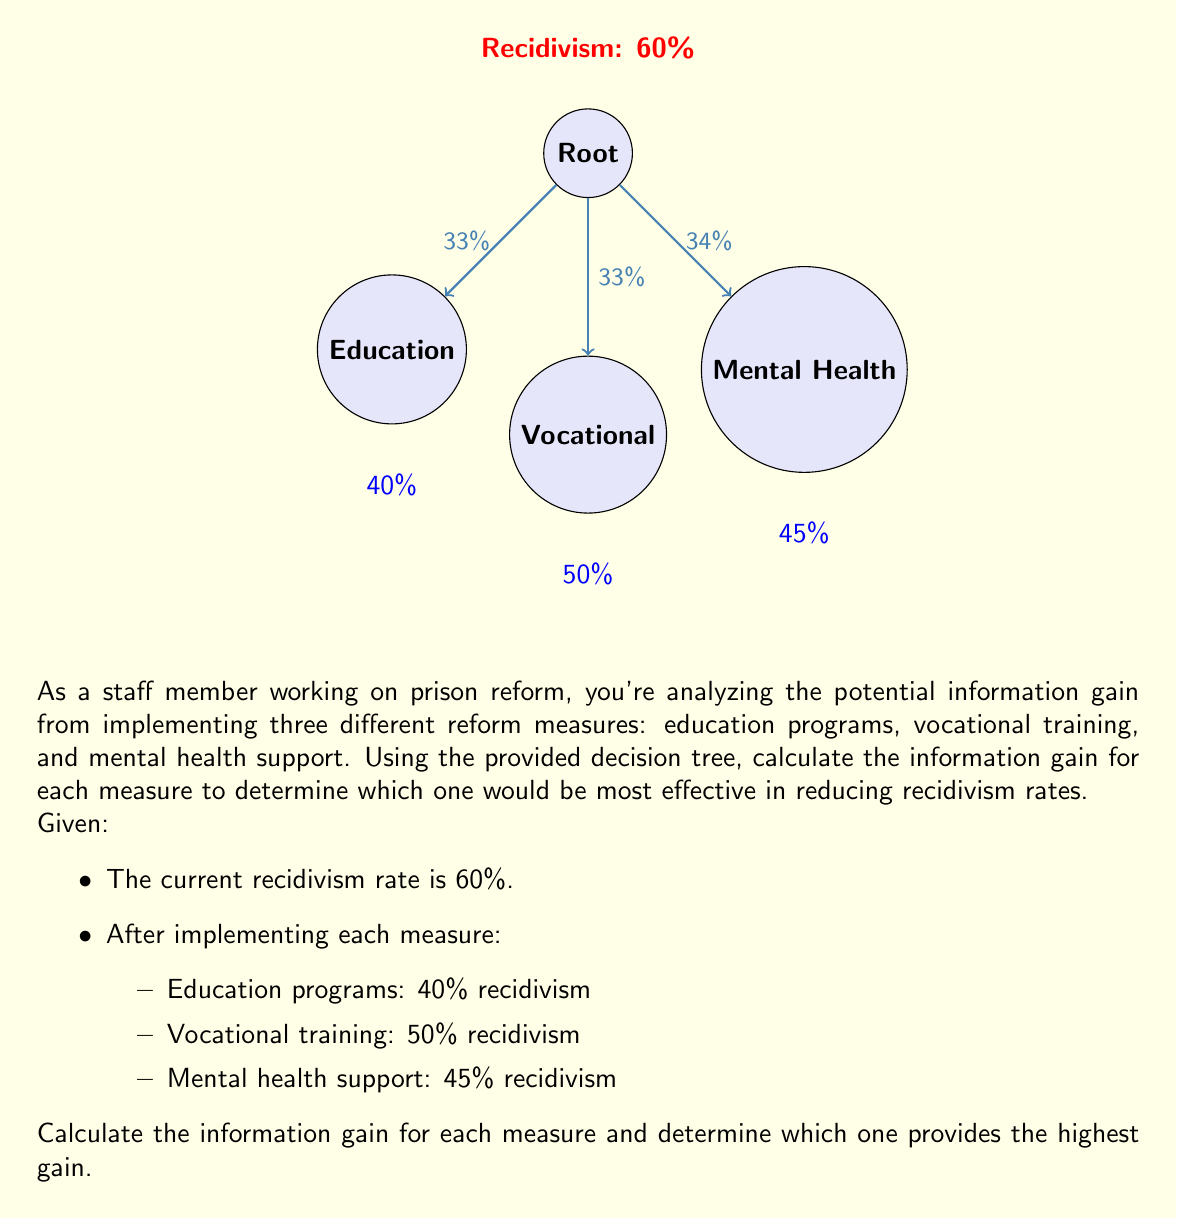Can you solve this math problem? To calculate the information gain, we need to follow these steps:

1. Calculate the entropy of the current system (before implementing any measure):
   $$H(S) = -p \log_2(p) - (1-p) \log_2(1-p)$$
   where $p$ is the probability of recidivism.

   $$H(S) = -0.6 \log_2(0.6) - 0.4 \log_2(0.4) = 0.971 \text{ bits}$$

2. Calculate the entropy after implementing each measure:

   For Education:
   $$H(S_E) = -0.4 \log_2(0.4) - 0.6 \log_2(0.6) = 0.971 \text{ bits}$$

   For Vocational:
   $$H(S_V) = -0.5 \log_2(0.5) - 0.5 \log_2(0.5) = 1 \text{ bit}$$

   For Mental Health:
   $$H(S_M) = -0.45 \log_2(0.45) - 0.55 \log_2(0.55) = 0.993 \text{ bits}$$

3. Calculate the weighted average entropy for each measure:

   Education: $0.33 \times 0.971 = 0.320 \text{ bits}$
   Vocational: $0.33 \times 1 = 0.330 \text{ bits}$
   Mental Health: $0.34 \times 0.993 = 0.338 \text{ bits}$

4. Calculate the information gain for each measure:
   $$\text{IG} = H(S) - H(S_\text{measure})$$

   Education: $0.971 - 0.320 = 0.651 \text{ bits}$
   Vocational: $0.971 - 0.330 = 0.641 \text{ bits}$
   Mental Health: $0.971 - 0.338 = 0.633 \text{ bits}$

5. Compare the information gains to determine which measure provides the highest gain.
Answer: Education programs provide the highest information gain of 0.651 bits. 